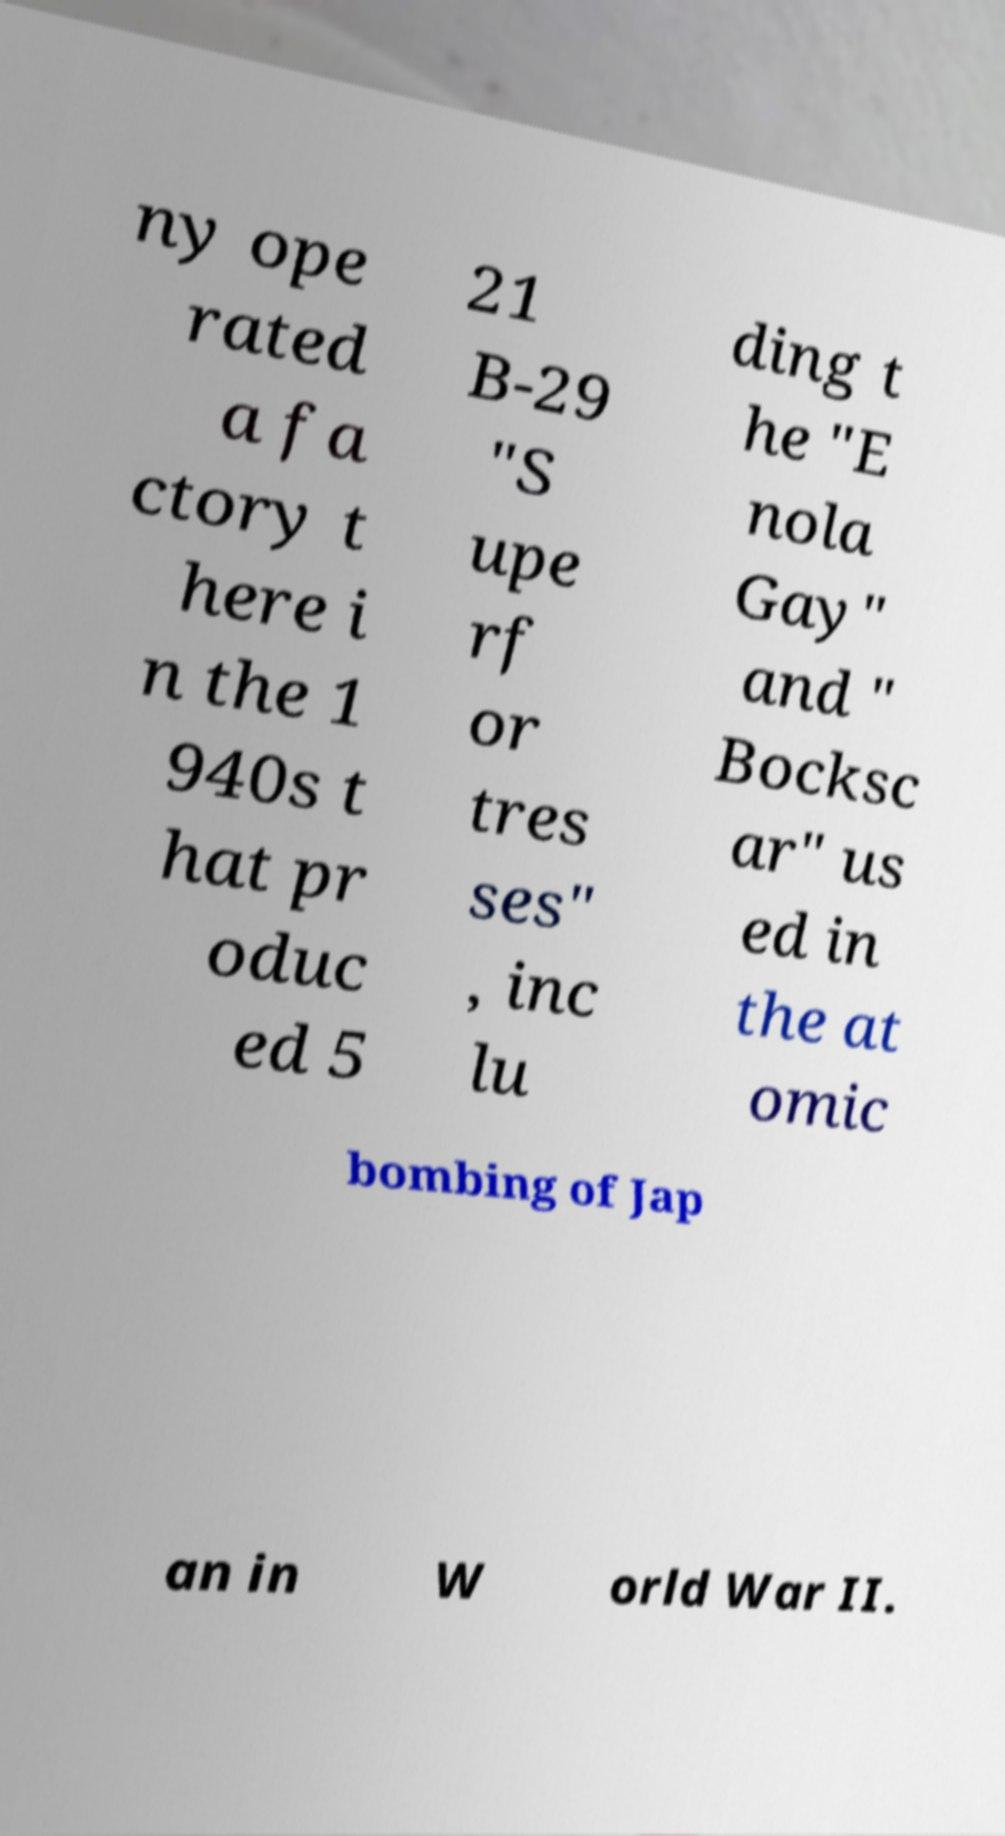For documentation purposes, I need the text within this image transcribed. Could you provide that? ny ope rated a fa ctory t here i n the 1 940s t hat pr oduc ed 5 21 B-29 "S upe rf or tres ses" , inc lu ding t he "E nola Gay" and " Bocksc ar" us ed in the at omic bombing of Jap an in W orld War II. 